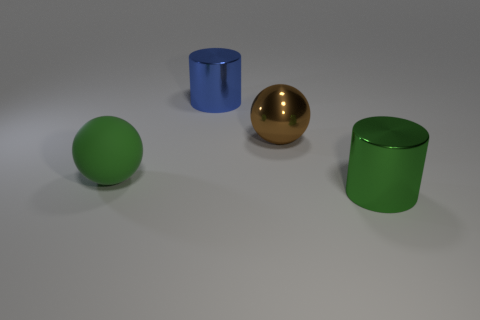Add 2 large rubber objects. How many objects exist? 6 Subtract all green cylinders. How many cylinders are left? 1 Add 3 metal objects. How many metal objects exist? 6 Subtract 1 green cylinders. How many objects are left? 3 Subtract all yellow cylinders. Subtract all blue spheres. How many cylinders are left? 2 Subtract all large cyan matte objects. Subtract all big brown spheres. How many objects are left? 3 Add 4 big shiny cylinders. How many big shiny cylinders are left? 6 